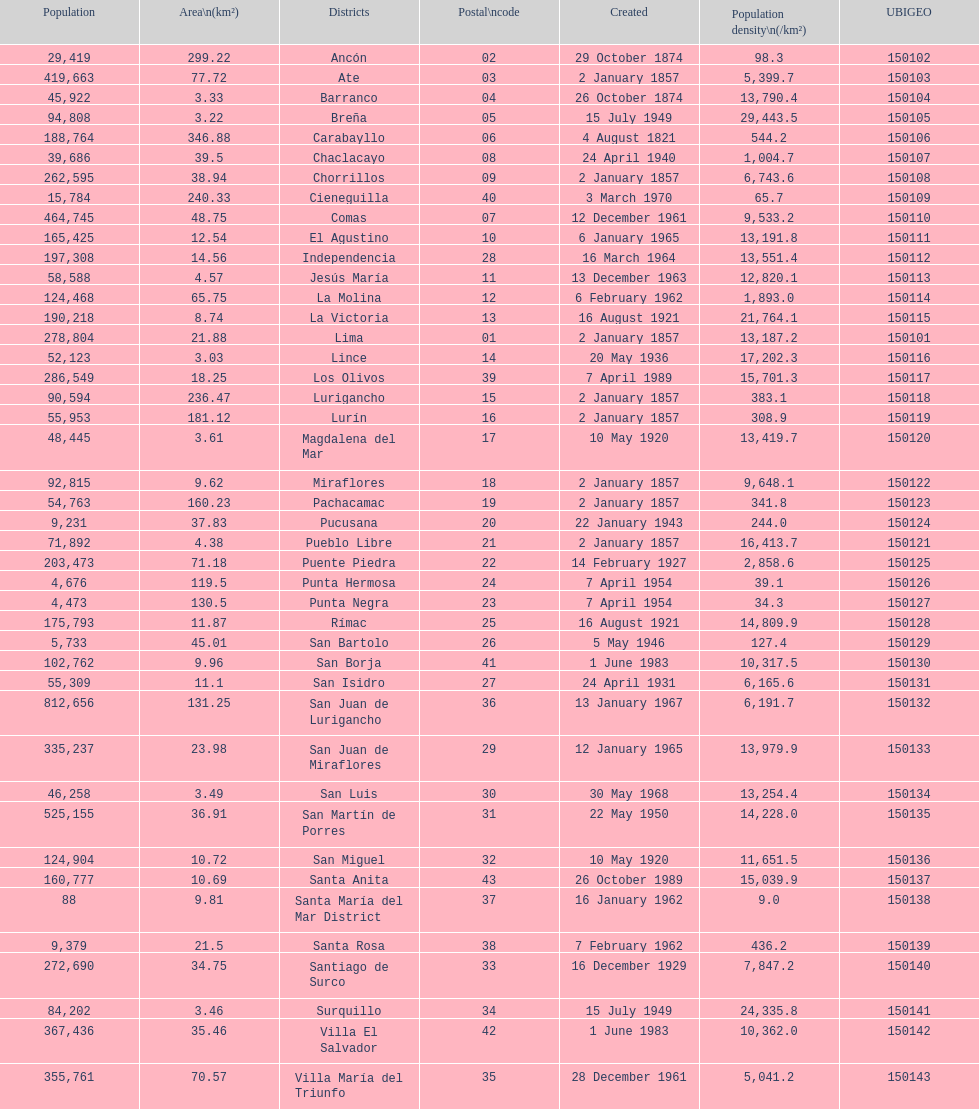Which district possesses the smallest number of inhabitants? Santa María del Mar District. 